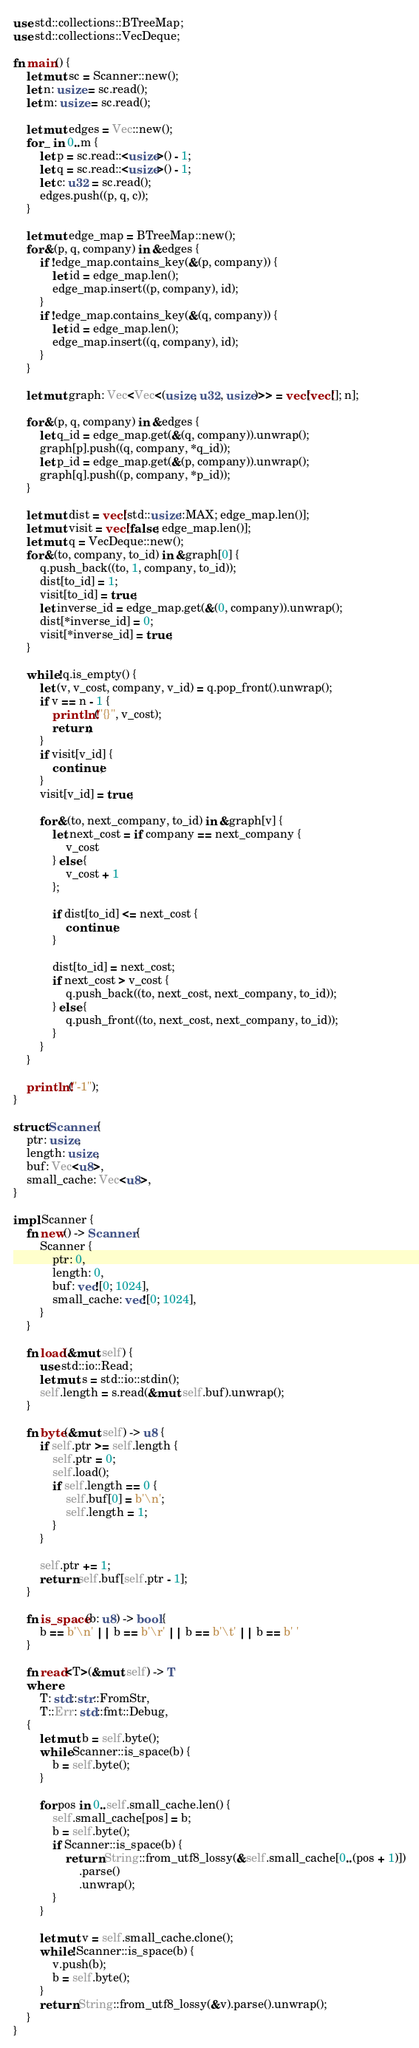<code> <loc_0><loc_0><loc_500><loc_500><_Rust_>use std::collections::BTreeMap;
use std::collections::VecDeque;

fn main() {
    let mut sc = Scanner::new();
    let n: usize = sc.read();
    let m: usize = sc.read();

    let mut edges = Vec::new();
    for _ in 0..m {
        let p = sc.read::<usize>() - 1;
        let q = sc.read::<usize>() - 1;
        let c: u32 = sc.read();
        edges.push((p, q, c));
    }

    let mut edge_map = BTreeMap::new();
    for &(p, q, company) in &edges {
        if !edge_map.contains_key(&(p, company)) {
            let id = edge_map.len();
            edge_map.insert((p, company), id);
        }
        if !edge_map.contains_key(&(q, company)) {
            let id = edge_map.len();
            edge_map.insert((q, company), id);
        }
    }

    let mut graph: Vec<Vec<(usize, u32, usize)>> = vec![vec![]; n];

    for &(p, q, company) in &edges {
        let q_id = edge_map.get(&(q, company)).unwrap();
        graph[p].push((q, company, *q_id));
        let p_id = edge_map.get(&(p, company)).unwrap();
        graph[q].push((p, company, *p_id));
    }

    let mut dist = vec![std::usize::MAX; edge_map.len()];
    let mut visit = vec![false; edge_map.len()];
    let mut q = VecDeque::new();
    for &(to, company, to_id) in &graph[0] {
        q.push_back((to, 1, company, to_id));
        dist[to_id] = 1;
        visit[to_id] = true;
        let inverse_id = edge_map.get(&(0, company)).unwrap();
        dist[*inverse_id] = 0;
        visit[*inverse_id] = true;
    }

    while !q.is_empty() {
        let (v, v_cost, company, v_id) = q.pop_front().unwrap();
        if v == n - 1 {
            println!("{}", v_cost);
            return;
        }
        if visit[v_id] {
            continue;
        }
        visit[v_id] = true;

        for &(to, next_company, to_id) in &graph[v] {
            let next_cost = if company == next_company {
                v_cost
            } else {
                v_cost + 1
            };

            if dist[to_id] <= next_cost {
                continue;
            }

            dist[to_id] = next_cost;
            if next_cost > v_cost {
                q.push_back((to, next_cost, next_company, to_id));
            } else {
                q.push_front((to, next_cost, next_company, to_id));
            }
        }
    }

    println!("-1");
}

struct Scanner {
    ptr: usize,
    length: usize,
    buf: Vec<u8>,
    small_cache: Vec<u8>,
}

impl Scanner {
    fn new() -> Scanner {
        Scanner {
            ptr: 0,
            length: 0,
            buf: vec![0; 1024],
            small_cache: vec![0; 1024],
        }
    }

    fn load(&mut self) {
        use std::io::Read;
        let mut s = std::io::stdin();
        self.length = s.read(&mut self.buf).unwrap();
    }

    fn byte(&mut self) -> u8 {
        if self.ptr >= self.length {
            self.ptr = 0;
            self.load();
            if self.length == 0 {
                self.buf[0] = b'\n';
                self.length = 1;
            }
        }

        self.ptr += 1;
        return self.buf[self.ptr - 1];
    }

    fn is_space(b: u8) -> bool {
        b == b'\n' || b == b'\r' || b == b'\t' || b == b' '
    }

    fn read<T>(&mut self) -> T
    where
        T: std::str::FromStr,
        T::Err: std::fmt::Debug,
    {
        let mut b = self.byte();
        while Scanner::is_space(b) {
            b = self.byte();
        }

        for pos in 0..self.small_cache.len() {
            self.small_cache[pos] = b;
            b = self.byte();
            if Scanner::is_space(b) {
                return String::from_utf8_lossy(&self.small_cache[0..(pos + 1)])
                    .parse()
                    .unwrap();
            }
        }

        let mut v = self.small_cache.clone();
        while !Scanner::is_space(b) {
            v.push(b);
            b = self.byte();
        }
        return String::from_utf8_lossy(&v).parse().unwrap();
    }
}
</code> 